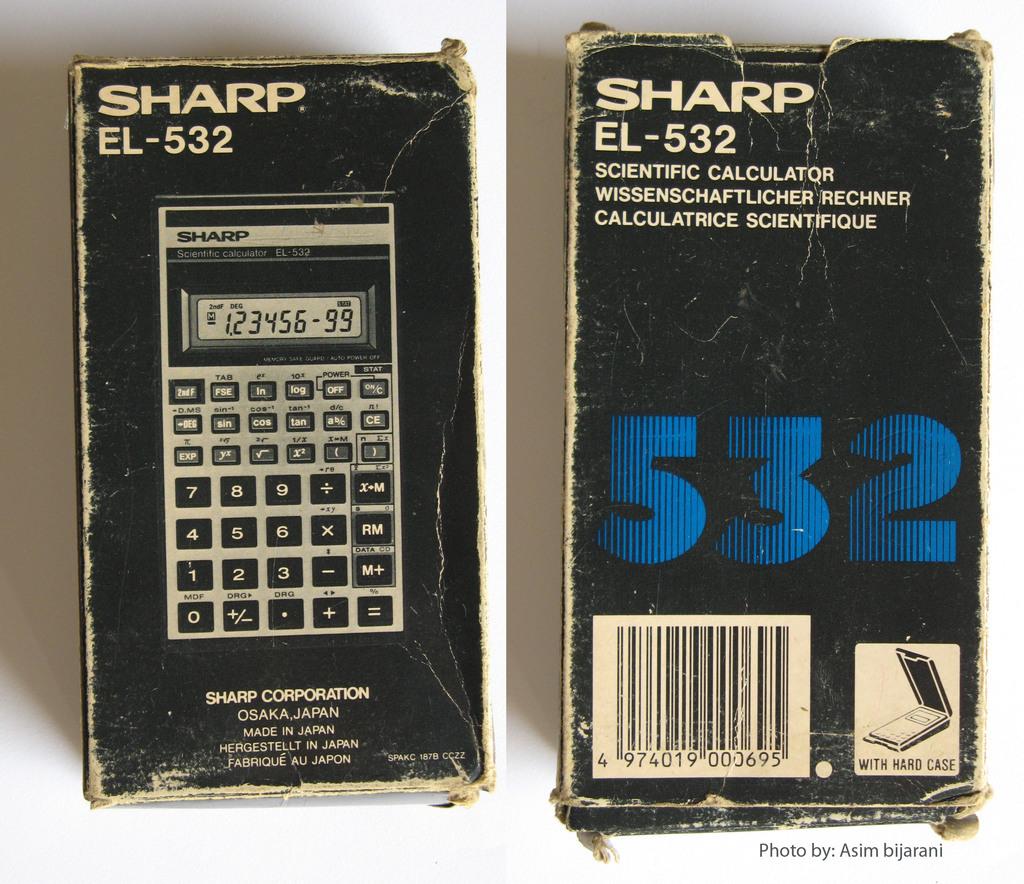What is shown the number?
Your response must be concise. 532. 